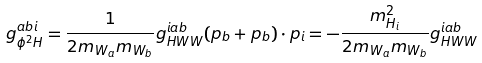Convert formula to latex. <formula><loc_0><loc_0><loc_500><loc_500>g ^ { a b i } _ { \phi ^ { 2 } H } = \frac { 1 } { 2 m _ { W _ { a } } m _ { W _ { b } } } g _ { H W W } ^ { i a b } ( p _ { b } + p _ { b } ) \cdot p _ { i } = - \frac { m _ { H _ { i } } ^ { 2 } } { 2 m _ { W _ { a } } m _ { W _ { b } } } g _ { H W W } ^ { i a b }</formula> 